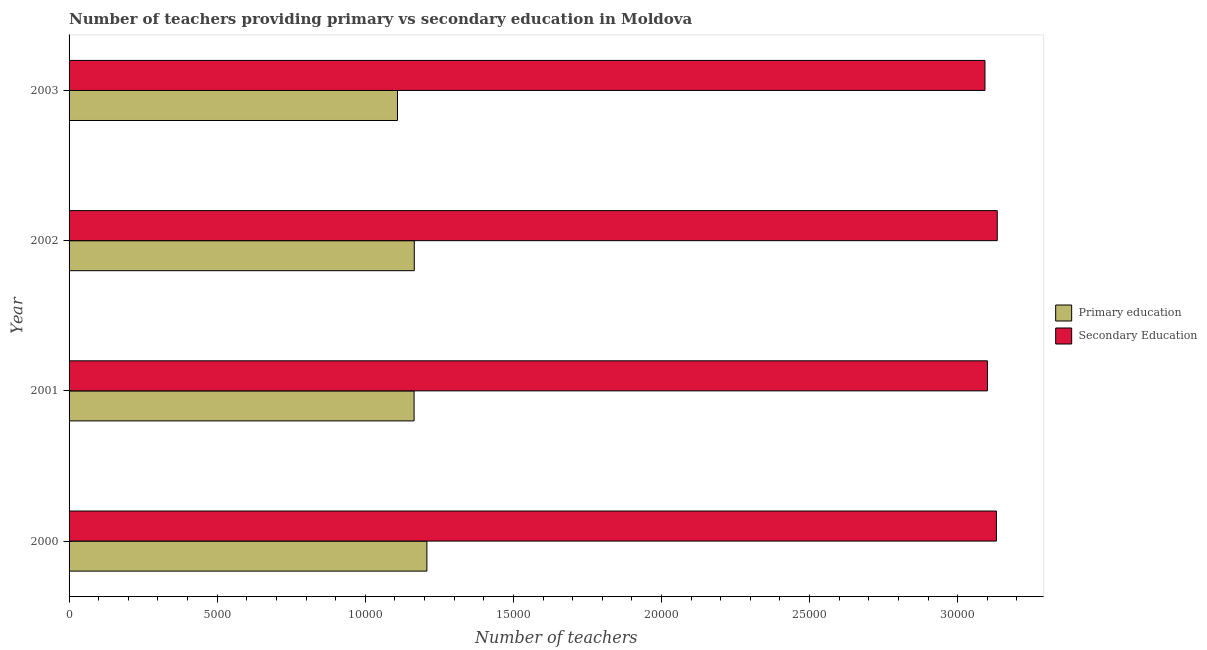How many different coloured bars are there?
Your answer should be very brief. 2. How many groups of bars are there?
Provide a succinct answer. 4. Are the number of bars on each tick of the Y-axis equal?
Offer a terse response. Yes. How many bars are there on the 1st tick from the top?
Offer a terse response. 2. How many bars are there on the 3rd tick from the bottom?
Provide a succinct answer. 2. What is the label of the 1st group of bars from the top?
Make the answer very short. 2003. What is the number of primary teachers in 2003?
Give a very brief answer. 1.11e+04. Across all years, what is the maximum number of primary teachers?
Provide a short and direct response. 1.21e+04. Across all years, what is the minimum number of secondary teachers?
Provide a succinct answer. 3.09e+04. In which year was the number of secondary teachers minimum?
Your answer should be compact. 2003. What is the total number of secondary teachers in the graph?
Your answer should be compact. 1.25e+05. What is the difference between the number of primary teachers in 2002 and that in 2003?
Offer a very short reply. 567. What is the difference between the number of secondary teachers in 2000 and the number of primary teachers in 2001?
Keep it short and to the point. 1.97e+04. What is the average number of secondary teachers per year?
Provide a short and direct response. 3.11e+04. In the year 2002, what is the difference between the number of primary teachers and number of secondary teachers?
Offer a very short reply. -1.97e+04. In how many years, is the number of primary teachers greater than 7000 ?
Give a very brief answer. 4. What is the ratio of the number of secondary teachers in 2002 to that in 2003?
Ensure brevity in your answer.  1.01. Is the number of primary teachers in 2002 less than that in 2003?
Offer a very short reply. No. Is the difference between the number of secondary teachers in 2000 and 2002 greater than the difference between the number of primary teachers in 2000 and 2002?
Your answer should be very brief. No. What is the difference between the highest and the second highest number of primary teachers?
Keep it short and to the point. 426. What is the difference between the highest and the lowest number of primary teachers?
Keep it short and to the point. 993. Is the sum of the number of secondary teachers in 2000 and 2001 greater than the maximum number of primary teachers across all years?
Keep it short and to the point. Yes. How many bars are there?
Your answer should be compact. 8. How many years are there in the graph?
Give a very brief answer. 4. What is the difference between two consecutive major ticks on the X-axis?
Your answer should be compact. 5000. How many legend labels are there?
Offer a very short reply. 2. What is the title of the graph?
Provide a short and direct response. Number of teachers providing primary vs secondary education in Moldova. Does "IMF nonconcessional" appear as one of the legend labels in the graph?
Provide a short and direct response. No. What is the label or title of the X-axis?
Provide a succinct answer. Number of teachers. What is the label or title of the Y-axis?
Ensure brevity in your answer.  Year. What is the Number of teachers in Primary education in 2000?
Offer a terse response. 1.21e+04. What is the Number of teachers in Secondary Education in 2000?
Provide a short and direct response. 3.13e+04. What is the Number of teachers of Primary education in 2001?
Make the answer very short. 1.16e+04. What is the Number of teachers in Secondary Education in 2001?
Your response must be concise. 3.10e+04. What is the Number of teachers of Primary education in 2002?
Make the answer very short. 1.17e+04. What is the Number of teachers in Secondary Education in 2002?
Offer a terse response. 3.13e+04. What is the Number of teachers in Primary education in 2003?
Provide a short and direct response. 1.11e+04. What is the Number of teachers of Secondary Education in 2003?
Keep it short and to the point. 3.09e+04. Across all years, what is the maximum Number of teachers of Primary education?
Offer a very short reply. 1.21e+04. Across all years, what is the maximum Number of teachers in Secondary Education?
Offer a terse response. 3.13e+04. Across all years, what is the minimum Number of teachers in Primary education?
Ensure brevity in your answer.  1.11e+04. Across all years, what is the minimum Number of teachers of Secondary Education?
Provide a short and direct response. 3.09e+04. What is the total Number of teachers in Primary education in the graph?
Ensure brevity in your answer.  4.65e+04. What is the total Number of teachers of Secondary Education in the graph?
Make the answer very short. 1.25e+05. What is the difference between the Number of teachers in Primary education in 2000 and that in 2001?
Give a very brief answer. 432. What is the difference between the Number of teachers in Secondary Education in 2000 and that in 2001?
Provide a short and direct response. 303. What is the difference between the Number of teachers in Primary education in 2000 and that in 2002?
Provide a succinct answer. 426. What is the difference between the Number of teachers of Secondary Education in 2000 and that in 2002?
Provide a short and direct response. -28. What is the difference between the Number of teachers of Primary education in 2000 and that in 2003?
Your answer should be compact. 993. What is the difference between the Number of teachers in Secondary Education in 2000 and that in 2003?
Make the answer very short. 387. What is the difference between the Number of teachers in Secondary Education in 2001 and that in 2002?
Your response must be concise. -331. What is the difference between the Number of teachers in Primary education in 2001 and that in 2003?
Give a very brief answer. 561. What is the difference between the Number of teachers in Primary education in 2002 and that in 2003?
Give a very brief answer. 567. What is the difference between the Number of teachers of Secondary Education in 2002 and that in 2003?
Your answer should be very brief. 415. What is the difference between the Number of teachers in Primary education in 2000 and the Number of teachers in Secondary Education in 2001?
Your response must be concise. -1.89e+04. What is the difference between the Number of teachers of Primary education in 2000 and the Number of teachers of Secondary Education in 2002?
Your answer should be compact. -1.93e+04. What is the difference between the Number of teachers of Primary education in 2000 and the Number of teachers of Secondary Education in 2003?
Offer a terse response. -1.88e+04. What is the difference between the Number of teachers in Primary education in 2001 and the Number of teachers in Secondary Education in 2002?
Make the answer very short. -1.97e+04. What is the difference between the Number of teachers of Primary education in 2001 and the Number of teachers of Secondary Education in 2003?
Offer a very short reply. -1.93e+04. What is the difference between the Number of teachers in Primary education in 2002 and the Number of teachers in Secondary Education in 2003?
Give a very brief answer. -1.93e+04. What is the average Number of teachers in Primary education per year?
Ensure brevity in your answer.  1.16e+04. What is the average Number of teachers of Secondary Education per year?
Ensure brevity in your answer.  3.11e+04. In the year 2000, what is the difference between the Number of teachers in Primary education and Number of teachers in Secondary Education?
Provide a short and direct response. -1.92e+04. In the year 2001, what is the difference between the Number of teachers of Primary education and Number of teachers of Secondary Education?
Your answer should be very brief. -1.94e+04. In the year 2002, what is the difference between the Number of teachers in Primary education and Number of teachers in Secondary Education?
Your answer should be compact. -1.97e+04. In the year 2003, what is the difference between the Number of teachers in Primary education and Number of teachers in Secondary Education?
Give a very brief answer. -1.98e+04. What is the ratio of the Number of teachers in Primary education in 2000 to that in 2001?
Give a very brief answer. 1.04. What is the ratio of the Number of teachers in Secondary Education in 2000 to that in 2001?
Provide a succinct answer. 1.01. What is the ratio of the Number of teachers of Primary education in 2000 to that in 2002?
Keep it short and to the point. 1.04. What is the ratio of the Number of teachers in Primary education in 2000 to that in 2003?
Give a very brief answer. 1.09. What is the ratio of the Number of teachers in Secondary Education in 2000 to that in 2003?
Keep it short and to the point. 1.01. What is the ratio of the Number of teachers in Primary education in 2001 to that in 2002?
Provide a short and direct response. 1. What is the ratio of the Number of teachers in Primary education in 2001 to that in 2003?
Provide a succinct answer. 1.05. What is the ratio of the Number of teachers in Primary education in 2002 to that in 2003?
Ensure brevity in your answer.  1.05. What is the ratio of the Number of teachers in Secondary Education in 2002 to that in 2003?
Provide a short and direct response. 1.01. What is the difference between the highest and the second highest Number of teachers in Primary education?
Give a very brief answer. 426. What is the difference between the highest and the lowest Number of teachers of Primary education?
Make the answer very short. 993. What is the difference between the highest and the lowest Number of teachers of Secondary Education?
Give a very brief answer. 415. 